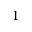<formula> <loc_0><loc_0><loc_500><loc_500>1</formula> 